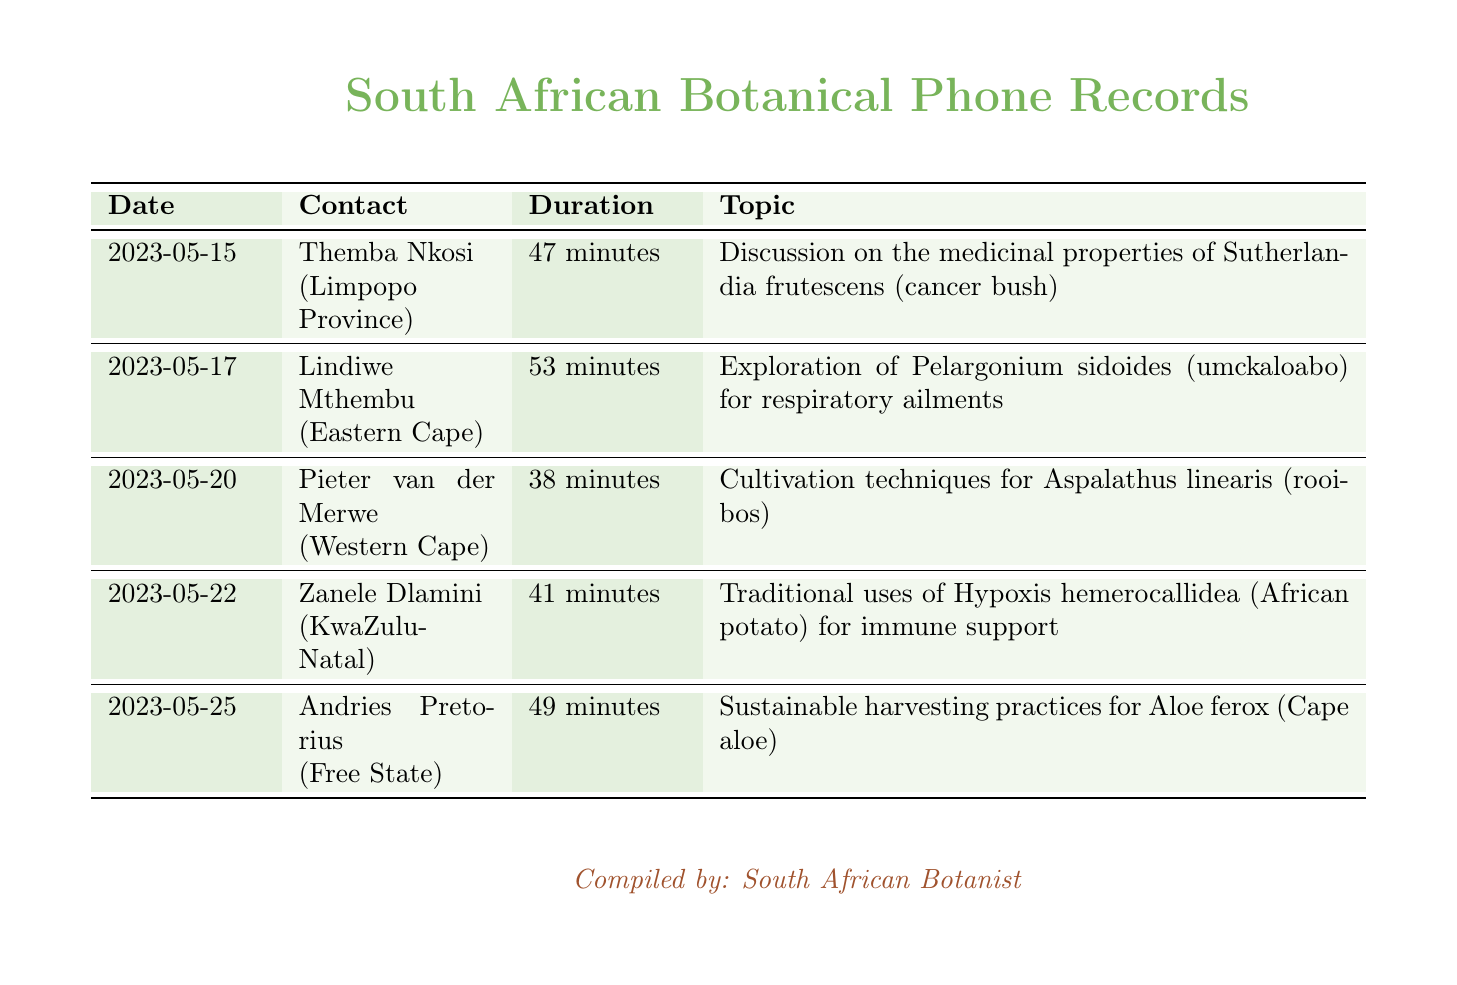What date did the conversation about Sutherlandia frutescens occur? The date of the discussion on Sutherlandia frutescens is listed in the document as 2023-05-15.
Answer: 2023-05-15 Who discussed the traditional uses of Hypoxis hemerocallidea? The document specifies that Zanele Dlamini discussed the traditional uses of Hypoxis hemerocallidea.
Answer: Zanele Dlamini What was the duration of the call with Lindiwe Mthembu? The duration of the conversation with Lindiwe Mthembu is 53 minutes, as noted in the call records.
Answer: 53 minutes Which plant was discussed in the call with Pieter van der Merwe? The plant discussed with Pieter van der Merwe was Aspalathus linearis, as stated in the document.
Answer: Aspalathus linearis How many minutes were spent discussing sustainable harvesting practices? The document indicates that 49 minutes were spent discussing sustainable harvesting practices for Aloe ferox.
Answer: 49 minutes What is the common name of Hypoxis hemerocallidea? The document provides the common name of Hypoxis hemerocallidea as African potato.
Answer: African potato How many calls mentioned cultivation techniques? There is one call mentioned in the document that discusses cultivation techniques, which is with Pieter van der Merwe.
Answer: 1 Which province did Themba Nkosi call from? The document states that Themba Nkosi is from Limpopo Province.
Answer: Limpopo Province What is the total number of discussions listed in the document? The document lists a total of five discussions about different indigenous plants.
Answer: 5 